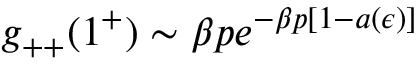Convert formula to latex. <formula><loc_0><loc_0><loc_500><loc_500>g _ { + + } ( 1 ^ { + } ) \sim \beta p e ^ { - \beta p [ 1 - a ( \epsilon ) ] }</formula> 